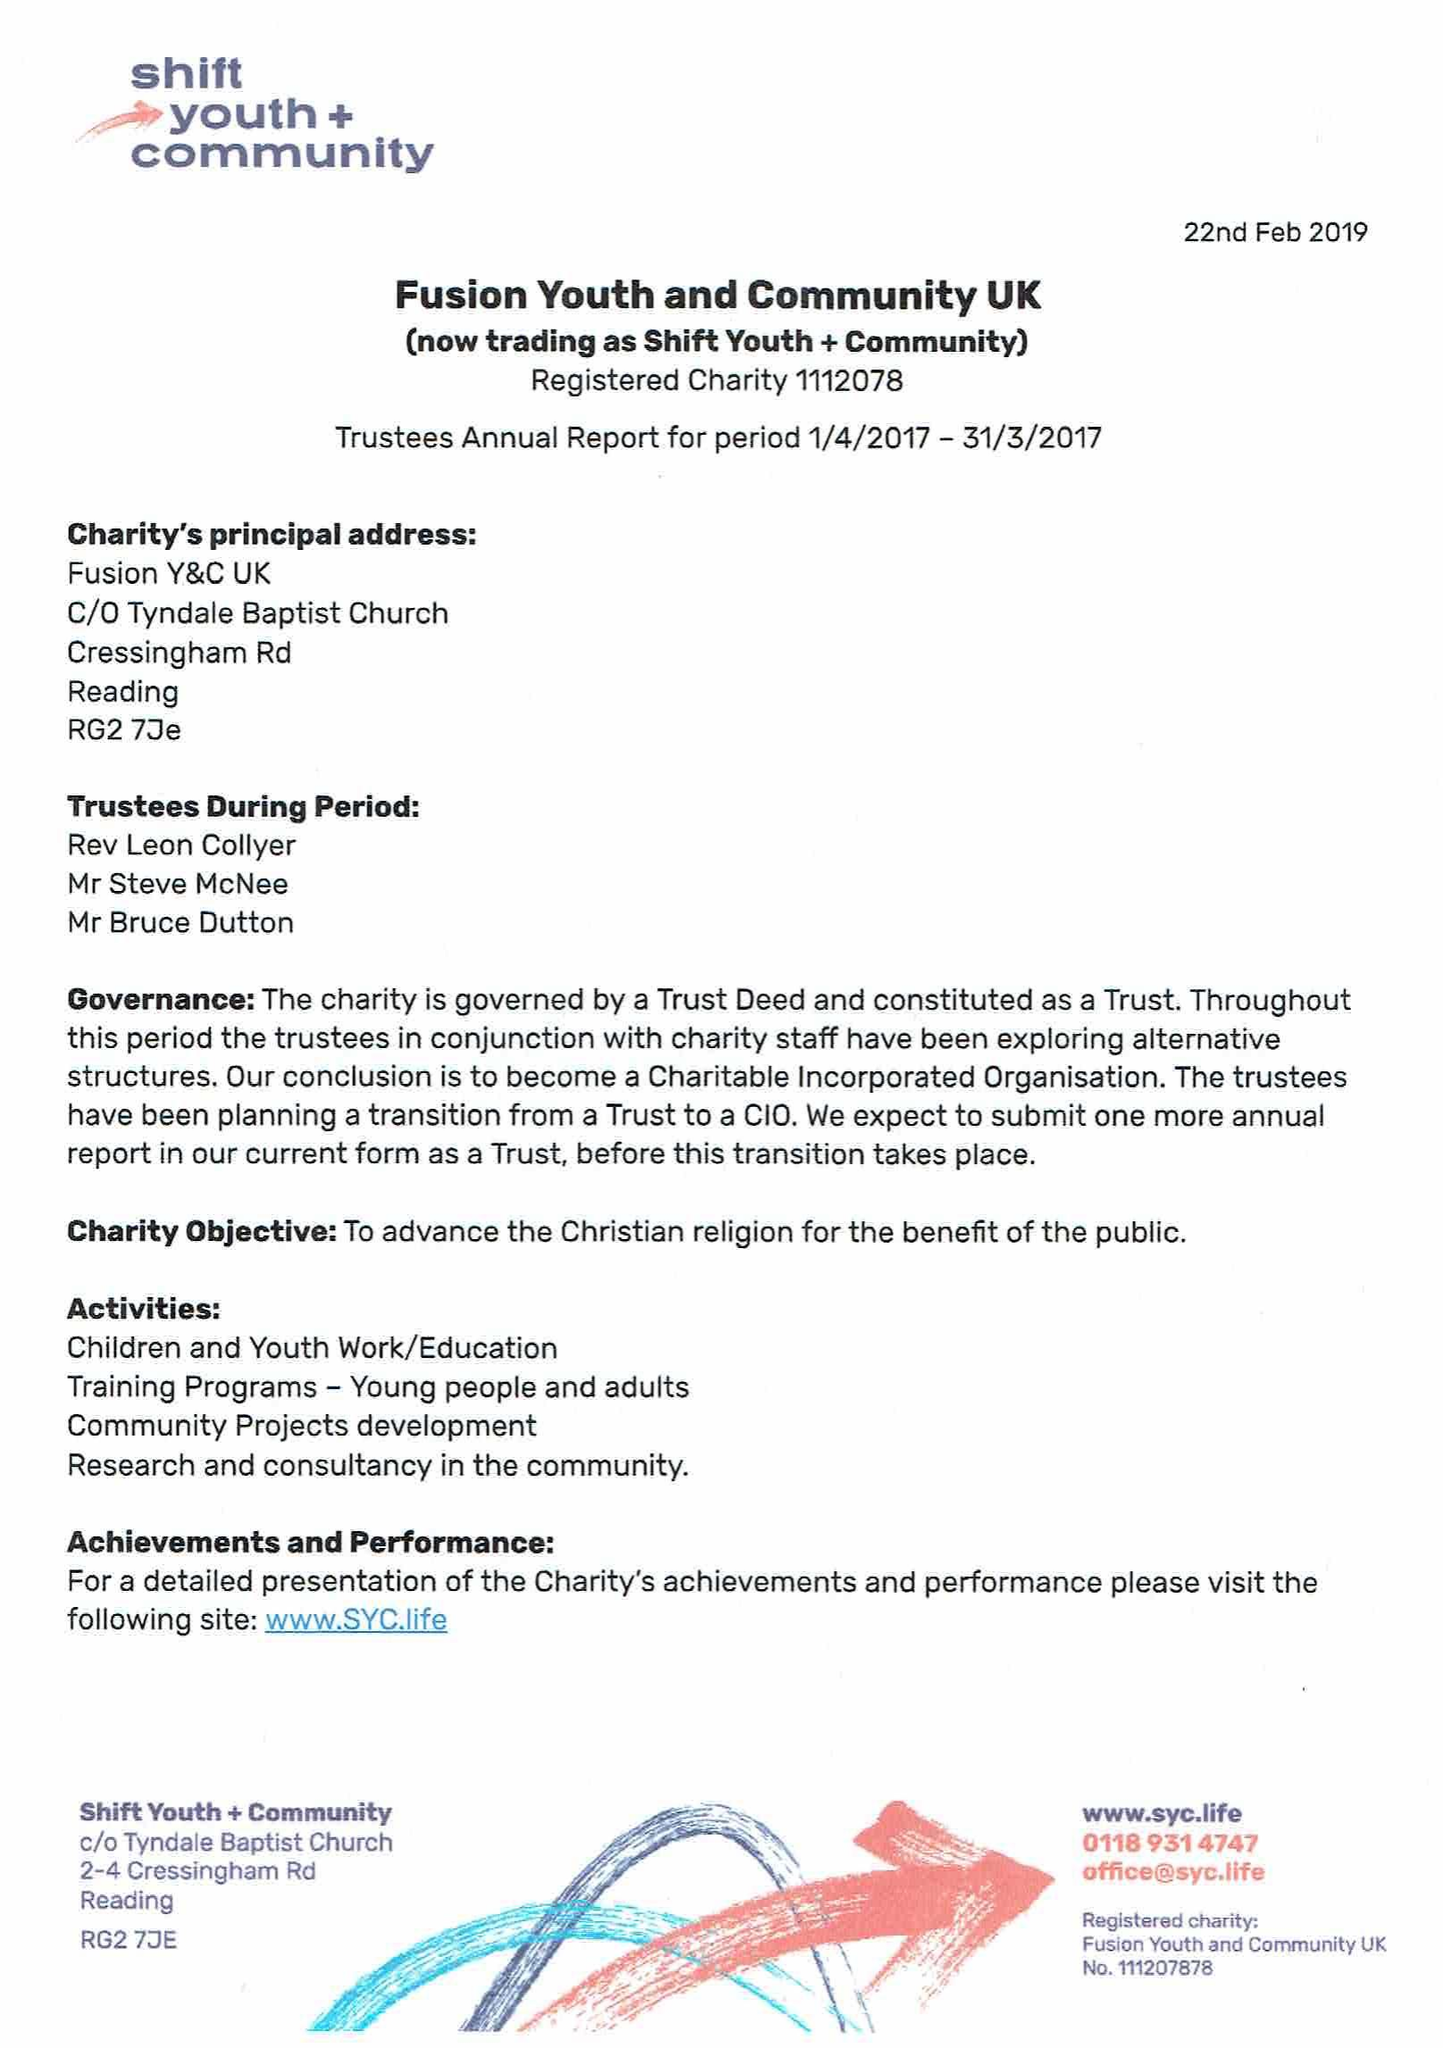What is the value for the report_date?
Answer the question using a single word or phrase. 2018-03-31 